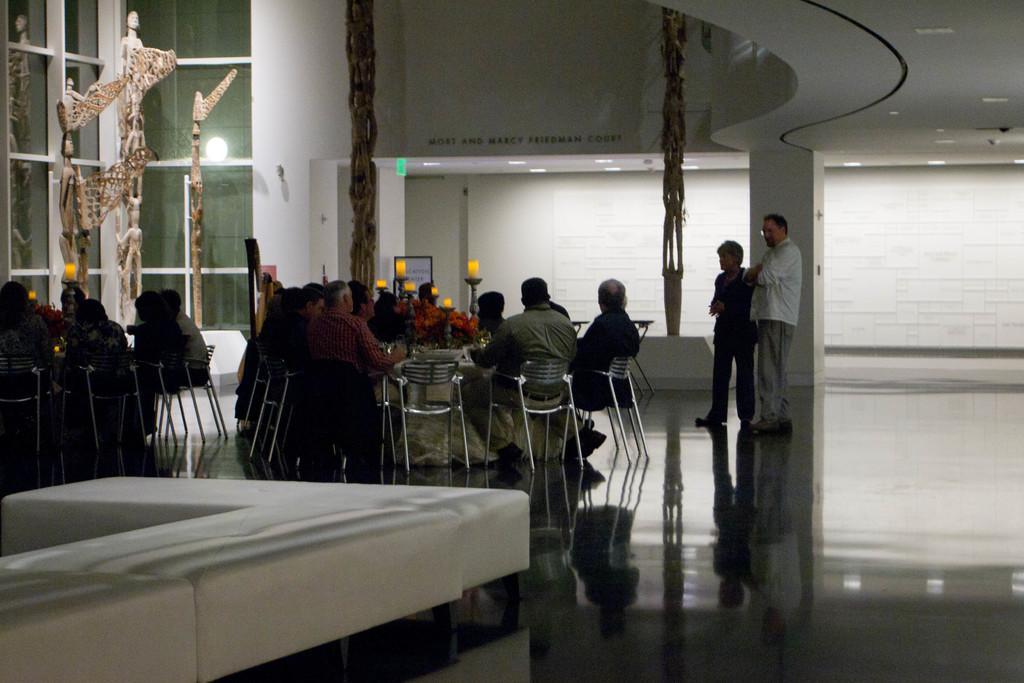How would you summarize this image in a sentence or two? In this image I can see group of people sitting. In front I can see two persons standing and the person at right is wearing white shirt, gray pant. Background I can see few statues and I can also see few glass windows and the wall is in white color. 